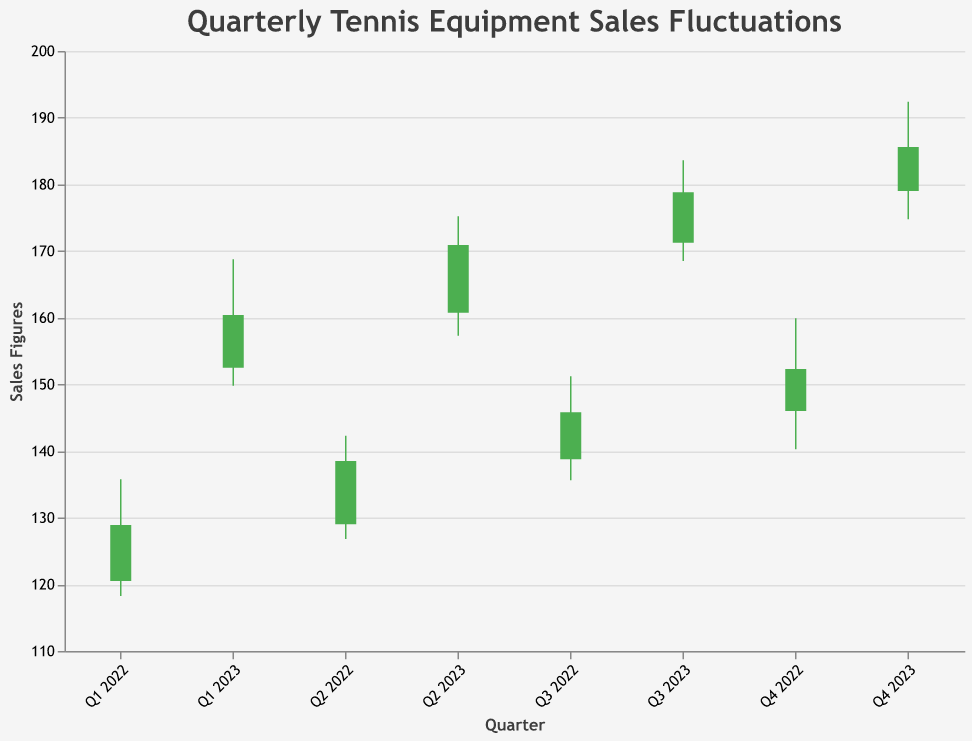How does the title of the chart describe the data? The title of the chart is "Quarterly Tennis Equipment Sales Fluctuations," which indicates that the data represents changes in the sales figures of tennis equipment on a quarterly basis. The term "fluctuations" suggests that the chart will show variability over the different quarters.
Answer: Quarterly Tennis Equipment Sales Fluctuations What is the maximum sales figure recorded in 2022? To find the maximum sales figure in 2022, we look at the "High" values for each quarter in 2022. The values are 135.75, 142.30, 151.20, and 159.90. The maximum among these is 159.90.
Answer: 159.90 Which quarter in 2022 had the largest increase in sales figures from Open to Close? To find the largest increase (difference between Open and Close) in 2022, calculate the difference for each quarter: Q1: 128.90 - 120.50 = 8.40, Q2: 138.50 - 129.00 = 9.50, Q3: 145.80 - 138.75 = 7.05, Q4: 152.30 - 146.00 = 6.30. The largest increase is in Q2, with a difference of 9.50.
Answer: Q2 2022 What trend can be observed in the Close values from Q1 2022 to Q4 2023? Observing the Close values from Q1 2022 (128.90) to Q4 2023 (185.60), we can see a generally increasing trend. Each quarter sees a higher Close value compared to the previous quarter, indicating a steady rise in sales figures.
Answer: Increasing trend How do sales figures in Q4 2022 compare to Q4 2023 in terms of Close values? The Close value for Q4 2022 is 152.30, and for Q4 2023, it is 185.60. By comparing these, we see that the sales figures have increased significantly from 152.30 in 2022 to 185.60 in 2023.
Answer: Increased What is the span of sales figures (from Low to High) for Q3 2023? The span of sales figures for Q3 2023 can be found by subtracting the Low value from the High value: 183.60 - 168.50 = 15.10.
Answer: 15.10 What is the average Close value for the quarters in 2022? To find the average Close value for 2022, add the Close values for each quarter (128.90, 138.50, 145.80, 152.30) and divide by 4: (128.90 + 138.50 + 145.80 + 152.30) / 4 = 141.88
Answer: 141.88 Which quarter experienced the lowest Low value in 2023? The Low values for the 2023 quarters are: Q1 (149.80), Q2 (157.30), Q3 (168.50), Q4 (174.75). The lowest value among these is 149.80, which occurred in Q1 2023.
Answer: Q1 2023 Between which consecutive quarters is the smallest range (difference between High and Low) observed in 2023? To find the smallest range in 2023, calculate the difference between High and Low for each quarter: Q1: 168.75 - 149.80 = 18.95, Q2: 175.20 - 157.30 = 17.90, Q3: 183.60 - 168.50 = 15.10, Q4: 192.40 - 174.75 = 17.65. The smallest range is in Q3 2023, with a difference of 15.10.
Answer: Q3 2023 